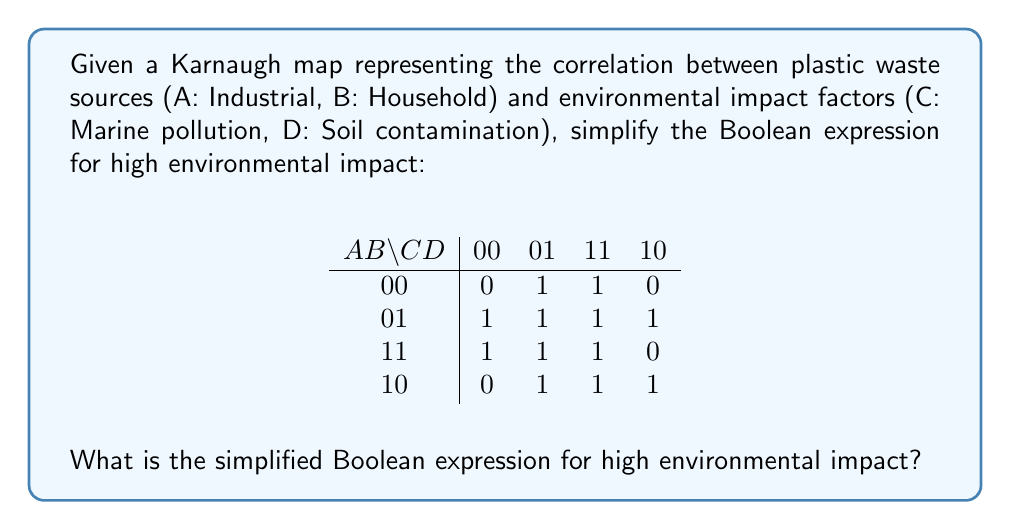Can you answer this question? To simplify the Boolean expression using the Karnaugh map:

1. Identify the largest possible groups of 1's:
   - Group 1: $\bar{A}B$ (4 cells)
   - Group 2: $BD$ (4 cells)
   - Group 3: $BC$ (4 cells)

2. Write the Boolean expression for each group:
   - Group 1: $\bar{A}B$
   - Group 2: $BD$
   - Group 3: $BC$

3. Combine the groups using the OR operator:
   $\bar{A}B + BD + BC$

4. Factor out common terms:
   $\bar{A}B + B(D + C)$

5. The final simplified Boolean expression is:
   $B(\bar{A} + C + D)$

This expression indicates that high environmental impact occurs when:
- Household waste (B) is present, AND
- Either industrial waste is absent ($\bar{A}$), OR marine pollution (C) is present, OR soil contamination (D) is present.
Answer: $B(\bar{A} + C + D)$ 